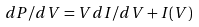Convert formula to latex. <formula><loc_0><loc_0><loc_500><loc_500>d P / d V = V d I / d V + I ( V )</formula> 